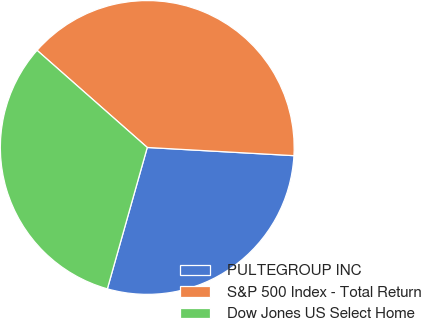Convert chart. <chart><loc_0><loc_0><loc_500><loc_500><pie_chart><fcel>PULTEGROUP INC<fcel>S&P 500 Index - Total Return<fcel>Dow Jones US Select Home<nl><fcel>28.49%<fcel>39.39%<fcel>32.12%<nl></chart> 